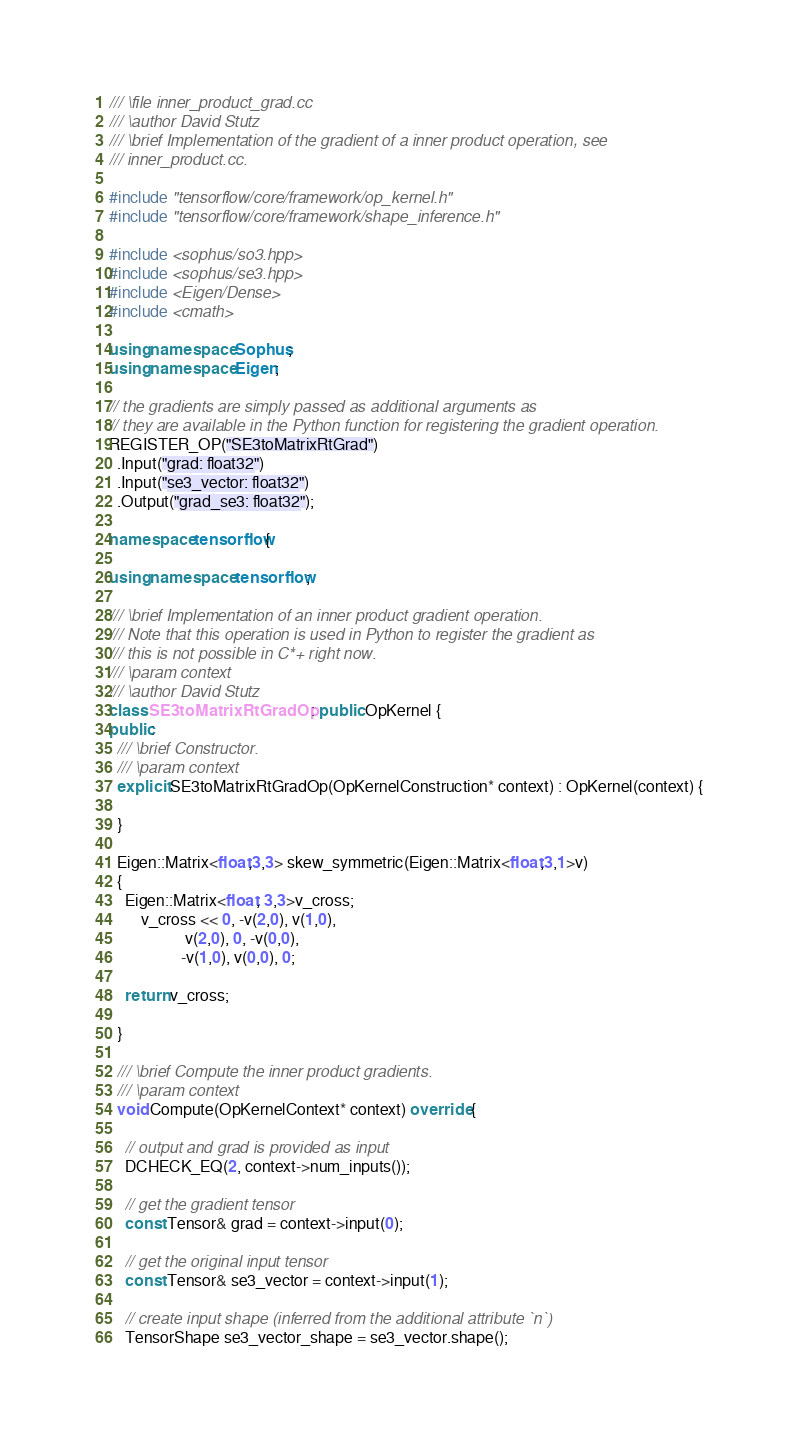<code> <loc_0><loc_0><loc_500><loc_500><_C++_>/// \file inner_product_grad.cc
/// \author David Stutz
/// \brief Implementation of the gradient of a inner product operation, see
/// inner_product.cc.

#include "tensorflow/core/framework/op_kernel.h"
#include "tensorflow/core/framework/shape_inference.h"

#include <sophus/so3.hpp>
#include <sophus/se3.hpp>
#include <Eigen/Dense>
#include <cmath>

using namespace Sophus;
using namespace Eigen;

// the gradients are simply passed as additional arguments as
// they are available in the Python function for registering the gradient operation.
REGISTER_OP("SE3toMatrixRtGrad")
  .Input("grad: float32")
  .Input("se3_vector: float32")
  .Output("grad_se3: float32");

namespace tensorflow{

using namespace tensorflow;

/// \brief Implementation of an inner product gradient operation.
/// Note that this operation is used in Python to register the gradient as
/// this is not possible in C*+ right now.
/// \param context
/// \author David Stutz
class SE3toMatrixRtGradOp : public OpKernel {
public:
  /// \brief Constructor.
  /// \param context
  explicit SE3toMatrixRtGradOp(OpKernelConstruction* context) : OpKernel(context) {

  }

  Eigen::Matrix<float,3,3> skew_symmetric(Eigen::Matrix<float,3,1>v)
  {
    Eigen::Matrix<float, 3,3>v_cross;
        v_cross << 0, -v(2,0), v(1,0),
                   v(2,0), 0, -v(0,0),
                  -v(1,0), v(0,0), 0;

    return v_cross;

  }

  /// \brief Compute the inner product gradients.
  /// \param context
  void Compute(OpKernelContext* context) override {

    // output and grad is provided as input
    DCHECK_EQ(2, context->num_inputs());

    // get the gradient tensor
    const Tensor& grad = context->input(0);

    // get the original input tensor
    const Tensor& se3_vector = context->input(1);

    // create input shape (inferred from the additional attribute `n`)
    TensorShape se3_vector_shape = se3_vector.shape();
</code> 